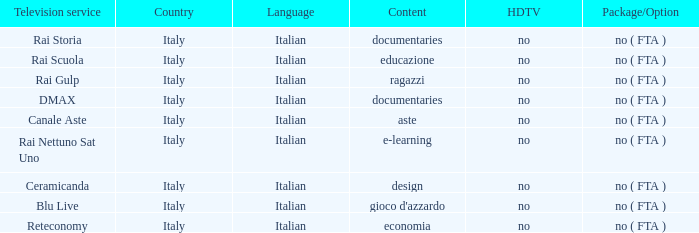What is the Language for Canale Aste? Italian. 